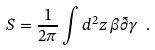<formula> <loc_0><loc_0><loc_500><loc_500>S = \frac { 1 } { 2 \pi } \int d ^ { 2 } z \, \beta \bar { \partial } \gamma \ .</formula> 